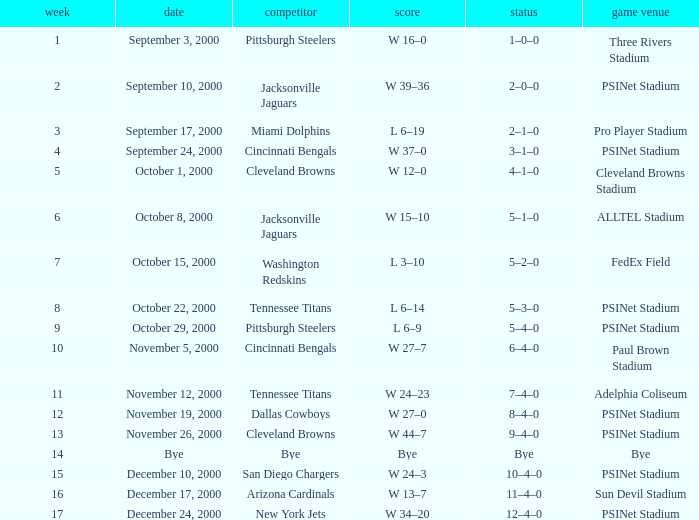What's the record for October 8, 2000 before week 13? 5–1–0. Could you parse the entire table as a dict? {'header': ['week', 'date', 'competitor', 'score', 'status', 'game venue'], 'rows': [['1', 'September 3, 2000', 'Pittsburgh Steelers', 'W 16–0', '1–0–0', 'Three Rivers Stadium'], ['2', 'September 10, 2000', 'Jacksonville Jaguars', 'W 39–36', '2–0–0', 'PSINet Stadium'], ['3', 'September 17, 2000', 'Miami Dolphins', 'L 6–19', '2–1–0', 'Pro Player Stadium'], ['4', 'September 24, 2000', 'Cincinnati Bengals', 'W 37–0', '3–1–0', 'PSINet Stadium'], ['5', 'October 1, 2000', 'Cleveland Browns', 'W 12–0', '4–1–0', 'Cleveland Browns Stadium'], ['6', 'October 8, 2000', 'Jacksonville Jaguars', 'W 15–10', '5–1–0', 'ALLTEL Stadium'], ['7', 'October 15, 2000', 'Washington Redskins', 'L 3–10', '5–2–0', 'FedEx Field'], ['8', 'October 22, 2000', 'Tennessee Titans', 'L 6–14', '5–3–0', 'PSINet Stadium'], ['9', 'October 29, 2000', 'Pittsburgh Steelers', 'L 6–9', '5–4–0', 'PSINet Stadium'], ['10', 'November 5, 2000', 'Cincinnati Bengals', 'W 27–7', '6–4–0', 'Paul Brown Stadium'], ['11', 'November 12, 2000', 'Tennessee Titans', 'W 24–23', '7–4–0', 'Adelphia Coliseum'], ['12', 'November 19, 2000', 'Dallas Cowboys', 'W 27–0', '8–4–0', 'PSINet Stadium'], ['13', 'November 26, 2000', 'Cleveland Browns', 'W 44–7', '9–4–0', 'PSINet Stadium'], ['14', 'Bye', 'Bye', 'Bye', 'Bye', 'Bye'], ['15', 'December 10, 2000', 'San Diego Chargers', 'W 24–3', '10–4–0', 'PSINet Stadium'], ['16', 'December 17, 2000', 'Arizona Cardinals', 'W 13–7', '11–4–0', 'Sun Devil Stadium'], ['17', 'December 24, 2000', 'New York Jets', 'W 34–20', '12–4–0', 'PSINet Stadium']]} 